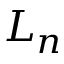Convert formula to latex. <formula><loc_0><loc_0><loc_500><loc_500>L _ { n }</formula> 